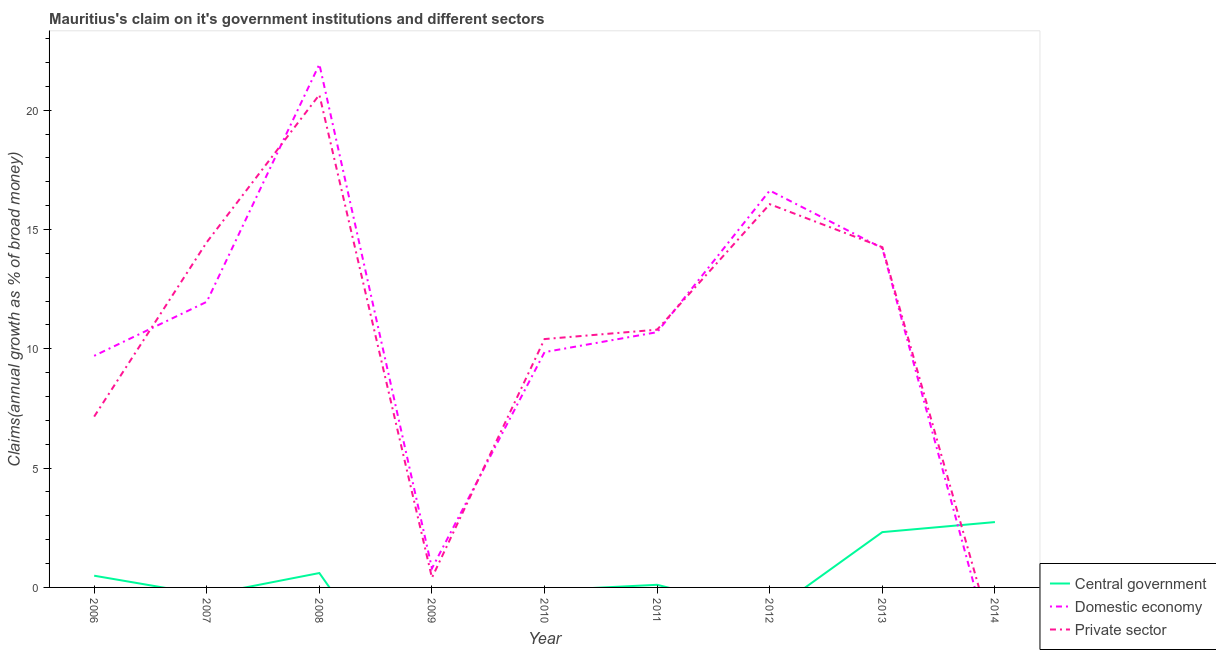How many different coloured lines are there?
Give a very brief answer. 3. Does the line corresponding to percentage of claim on the private sector intersect with the line corresponding to percentage of claim on the central government?
Provide a succinct answer. Yes. What is the percentage of claim on the private sector in 2008?
Your answer should be very brief. 20.65. Across all years, what is the maximum percentage of claim on the central government?
Provide a succinct answer. 2.74. Across all years, what is the minimum percentage of claim on the domestic economy?
Offer a very short reply. 0. In which year was the percentage of claim on the domestic economy maximum?
Provide a succinct answer. 2008. What is the total percentage of claim on the central government in the graph?
Ensure brevity in your answer.  6.26. What is the difference between the percentage of claim on the domestic economy in 2010 and that in 2013?
Your answer should be compact. -4.36. What is the difference between the percentage of claim on the private sector in 2007 and the percentage of claim on the central government in 2010?
Your answer should be very brief. 14.47. What is the average percentage of claim on the central government per year?
Provide a short and direct response. 0.7. In the year 2009, what is the difference between the percentage of claim on the domestic economy and percentage of claim on the private sector?
Give a very brief answer. 0.39. What is the ratio of the percentage of claim on the domestic economy in 2006 to that in 2007?
Your response must be concise. 0.81. Is the percentage of claim on the private sector in 2011 less than that in 2012?
Ensure brevity in your answer.  Yes. Is the difference between the percentage of claim on the private sector in 2006 and 2012 greater than the difference between the percentage of claim on the domestic economy in 2006 and 2012?
Provide a short and direct response. No. What is the difference between the highest and the second highest percentage of claim on the central government?
Provide a succinct answer. 0.42. What is the difference between the highest and the lowest percentage of claim on the domestic economy?
Your response must be concise. 21.92. In how many years, is the percentage of claim on the central government greater than the average percentage of claim on the central government taken over all years?
Offer a very short reply. 2. Is it the case that in every year, the sum of the percentage of claim on the central government and percentage of claim on the domestic economy is greater than the percentage of claim on the private sector?
Offer a terse response. No. Is the percentage of claim on the central government strictly greater than the percentage of claim on the domestic economy over the years?
Make the answer very short. No. Is the percentage of claim on the domestic economy strictly less than the percentage of claim on the private sector over the years?
Provide a short and direct response. No. Does the graph contain any zero values?
Keep it short and to the point. Yes. Does the graph contain grids?
Offer a very short reply. No. How many legend labels are there?
Your answer should be very brief. 3. What is the title of the graph?
Make the answer very short. Mauritius's claim on it's government institutions and different sectors. Does "Resident buildings and public services" appear as one of the legend labels in the graph?
Provide a succinct answer. No. What is the label or title of the Y-axis?
Provide a short and direct response. Claims(annual growth as % of broad money). What is the Claims(annual growth as % of broad money) in Central government in 2006?
Make the answer very short. 0.49. What is the Claims(annual growth as % of broad money) of Domestic economy in 2006?
Make the answer very short. 9.7. What is the Claims(annual growth as % of broad money) of Private sector in 2006?
Offer a very short reply. 7.16. What is the Claims(annual growth as % of broad money) in Central government in 2007?
Keep it short and to the point. 0. What is the Claims(annual growth as % of broad money) in Domestic economy in 2007?
Your answer should be compact. 11.97. What is the Claims(annual growth as % of broad money) in Private sector in 2007?
Your answer should be very brief. 14.47. What is the Claims(annual growth as % of broad money) in Central government in 2008?
Your answer should be very brief. 0.6. What is the Claims(annual growth as % of broad money) of Domestic economy in 2008?
Keep it short and to the point. 21.92. What is the Claims(annual growth as % of broad money) in Private sector in 2008?
Your response must be concise. 20.65. What is the Claims(annual growth as % of broad money) in Domestic economy in 2009?
Make the answer very short. 0.8. What is the Claims(annual growth as % of broad money) of Private sector in 2009?
Provide a short and direct response. 0.41. What is the Claims(annual growth as % of broad money) of Domestic economy in 2010?
Keep it short and to the point. 9.86. What is the Claims(annual growth as % of broad money) of Private sector in 2010?
Keep it short and to the point. 10.41. What is the Claims(annual growth as % of broad money) in Central government in 2011?
Offer a terse response. 0.11. What is the Claims(annual growth as % of broad money) in Domestic economy in 2011?
Keep it short and to the point. 10.7. What is the Claims(annual growth as % of broad money) of Private sector in 2011?
Your answer should be very brief. 10.8. What is the Claims(annual growth as % of broad money) of Domestic economy in 2012?
Provide a short and direct response. 16.63. What is the Claims(annual growth as % of broad money) of Private sector in 2012?
Offer a very short reply. 16.06. What is the Claims(annual growth as % of broad money) of Central government in 2013?
Your answer should be compact. 2.32. What is the Claims(annual growth as % of broad money) in Domestic economy in 2013?
Your answer should be very brief. 14.22. What is the Claims(annual growth as % of broad money) of Private sector in 2013?
Ensure brevity in your answer.  14.26. What is the Claims(annual growth as % of broad money) in Central government in 2014?
Offer a very short reply. 2.74. Across all years, what is the maximum Claims(annual growth as % of broad money) in Central government?
Offer a very short reply. 2.74. Across all years, what is the maximum Claims(annual growth as % of broad money) of Domestic economy?
Provide a short and direct response. 21.92. Across all years, what is the maximum Claims(annual growth as % of broad money) in Private sector?
Provide a succinct answer. 20.65. Across all years, what is the minimum Claims(annual growth as % of broad money) in Domestic economy?
Your answer should be compact. 0. What is the total Claims(annual growth as % of broad money) in Central government in the graph?
Your answer should be very brief. 6.26. What is the total Claims(annual growth as % of broad money) in Domestic economy in the graph?
Your answer should be compact. 95.8. What is the total Claims(annual growth as % of broad money) in Private sector in the graph?
Provide a short and direct response. 94.2. What is the difference between the Claims(annual growth as % of broad money) in Domestic economy in 2006 and that in 2007?
Provide a succinct answer. -2.27. What is the difference between the Claims(annual growth as % of broad money) in Private sector in 2006 and that in 2007?
Give a very brief answer. -7.31. What is the difference between the Claims(annual growth as % of broad money) in Central government in 2006 and that in 2008?
Ensure brevity in your answer.  -0.11. What is the difference between the Claims(annual growth as % of broad money) in Domestic economy in 2006 and that in 2008?
Make the answer very short. -12.22. What is the difference between the Claims(annual growth as % of broad money) in Private sector in 2006 and that in 2008?
Keep it short and to the point. -13.49. What is the difference between the Claims(annual growth as % of broad money) in Domestic economy in 2006 and that in 2009?
Keep it short and to the point. 8.91. What is the difference between the Claims(annual growth as % of broad money) of Private sector in 2006 and that in 2009?
Ensure brevity in your answer.  6.75. What is the difference between the Claims(annual growth as % of broad money) in Domestic economy in 2006 and that in 2010?
Keep it short and to the point. -0.16. What is the difference between the Claims(annual growth as % of broad money) of Private sector in 2006 and that in 2010?
Give a very brief answer. -3.25. What is the difference between the Claims(annual growth as % of broad money) of Central government in 2006 and that in 2011?
Your answer should be compact. 0.38. What is the difference between the Claims(annual growth as % of broad money) in Domestic economy in 2006 and that in 2011?
Offer a very short reply. -0.99. What is the difference between the Claims(annual growth as % of broad money) in Private sector in 2006 and that in 2011?
Keep it short and to the point. -3.64. What is the difference between the Claims(annual growth as % of broad money) in Domestic economy in 2006 and that in 2012?
Keep it short and to the point. -6.93. What is the difference between the Claims(annual growth as % of broad money) of Private sector in 2006 and that in 2012?
Provide a succinct answer. -8.9. What is the difference between the Claims(annual growth as % of broad money) in Central government in 2006 and that in 2013?
Your answer should be very brief. -1.83. What is the difference between the Claims(annual growth as % of broad money) of Domestic economy in 2006 and that in 2013?
Your answer should be very brief. -4.51. What is the difference between the Claims(annual growth as % of broad money) in Private sector in 2006 and that in 2013?
Your response must be concise. -7.1. What is the difference between the Claims(annual growth as % of broad money) of Central government in 2006 and that in 2014?
Offer a terse response. -2.25. What is the difference between the Claims(annual growth as % of broad money) in Domestic economy in 2007 and that in 2008?
Offer a very short reply. -9.95. What is the difference between the Claims(annual growth as % of broad money) of Private sector in 2007 and that in 2008?
Provide a succinct answer. -6.18. What is the difference between the Claims(annual growth as % of broad money) in Domestic economy in 2007 and that in 2009?
Offer a terse response. 11.17. What is the difference between the Claims(annual growth as % of broad money) of Private sector in 2007 and that in 2009?
Your answer should be compact. 14.06. What is the difference between the Claims(annual growth as % of broad money) of Domestic economy in 2007 and that in 2010?
Your answer should be very brief. 2.11. What is the difference between the Claims(annual growth as % of broad money) in Private sector in 2007 and that in 2010?
Give a very brief answer. 4.06. What is the difference between the Claims(annual growth as % of broad money) in Domestic economy in 2007 and that in 2011?
Keep it short and to the point. 1.27. What is the difference between the Claims(annual growth as % of broad money) of Private sector in 2007 and that in 2011?
Your answer should be very brief. 3.67. What is the difference between the Claims(annual growth as % of broad money) in Domestic economy in 2007 and that in 2012?
Provide a succinct answer. -4.66. What is the difference between the Claims(annual growth as % of broad money) of Private sector in 2007 and that in 2012?
Offer a terse response. -1.59. What is the difference between the Claims(annual growth as % of broad money) of Domestic economy in 2007 and that in 2013?
Offer a very short reply. -2.25. What is the difference between the Claims(annual growth as % of broad money) in Private sector in 2007 and that in 2013?
Your response must be concise. 0.21. What is the difference between the Claims(annual growth as % of broad money) in Domestic economy in 2008 and that in 2009?
Ensure brevity in your answer.  21.12. What is the difference between the Claims(annual growth as % of broad money) in Private sector in 2008 and that in 2009?
Your answer should be compact. 20.24. What is the difference between the Claims(annual growth as % of broad money) of Domestic economy in 2008 and that in 2010?
Give a very brief answer. 12.06. What is the difference between the Claims(annual growth as % of broad money) of Private sector in 2008 and that in 2010?
Your response must be concise. 10.24. What is the difference between the Claims(annual growth as % of broad money) of Central government in 2008 and that in 2011?
Your response must be concise. 0.49. What is the difference between the Claims(annual growth as % of broad money) in Domestic economy in 2008 and that in 2011?
Provide a succinct answer. 11.23. What is the difference between the Claims(annual growth as % of broad money) of Private sector in 2008 and that in 2011?
Make the answer very short. 9.84. What is the difference between the Claims(annual growth as % of broad money) of Domestic economy in 2008 and that in 2012?
Your answer should be compact. 5.29. What is the difference between the Claims(annual growth as % of broad money) of Private sector in 2008 and that in 2012?
Make the answer very short. 4.59. What is the difference between the Claims(annual growth as % of broad money) of Central government in 2008 and that in 2013?
Your answer should be compact. -1.72. What is the difference between the Claims(annual growth as % of broad money) in Domestic economy in 2008 and that in 2013?
Provide a succinct answer. 7.7. What is the difference between the Claims(annual growth as % of broad money) of Private sector in 2008 and that in 2013?
Give a very brief answer. 6.39. What is the difference between the Claims(annual growth as % of broad money) of Central government in 2008 and that in 2014?
Your response must be concise. -2.14. What is the difference between the Claims(annual growth as % of broad money) in Domestic economy in 2009 and that in 2010?
Your answer should be very brief. -9.06. What is the difference between the Claims(annual growth as % of broad money) of Private sector in 2009 and that in 2010?
Keep it short and to the point. -10. What is the difference between the Claims(annual growth as % of broad money) in Domestic economy in 2009 and that in 2011?
Your answer should be compact. -9.9. What is the difference between the Claims(annual growth as % of broad money) in Private sector in 2009 and that in 2011?
Offer a very short reply. -10.39. What is the difference between the Claims(annual growth as % of broad money) in Domestic economy in 2009 and that in 2012?
Provide a succinct answer. -15.83. What is the difference between the Claims(annual growth as % of broad money) of Private sector in 2009 and that in 2012?
Provide a succinct answer. -15.65. What is the difference between the Claims(annual growth as % of broad money) of Domestic economy in 2009 and that in 2013?
Provide a short and direct response. -13.42. What is the difference between the Claims(annual growth as % of broad money) of Private sector in 2009 and that in 2013?
Ensure brevity in your answer.  -13.85. What is the difference between the Claims(annual growth as % of broad money) of Domestic economy in 2010 and that in 2011?
Your response must be concise. -0.84. What is the difference between the Claims(annual growth as % of broad money) in Private sector in 2010 and that in 2011?
Your response must be concise. -0.39. What is the difference between the Claims(annual growth as % of broad money) in Domestic economy in 2010 and that in 2012?
Your answer should be compact. -6.77. What is the difference between the Claims(annual growth as % of broad money) in Private sector in 2010 and that in 2012?
Provide a short and direct response. -5.65. What is the difference between the Claims(annual growth as % of broad money) of Domestic economy in 2010 and that in 2013?
Ensure brevity in your answer.  -4.36. What is the difference between the Claims(annual growth as % of broad money) in Private sector in 2010 and that in 2013?
Your answer should be very brief. -3.85. What is the difference between the Claims(annual growth as % of broad money) of Domestic economy in 2011 and that in 2012?
Give a very brief answer. -5.93. What is the difference between the Claims(annual growth as % of broad money) in Private sector in 2011 and that in 2012?
Give a very brief answer. -5.26. What is the difference between the Claims(annual growth as % of broad money) of Central government in 2011 and that in 2013?
Make the answer very short. -2.21. What is the difference between the Claims(annual growth as % of broad money) of Domestic economy in 2011 and that in 2013?
Ensure brevity in your answer.  -3.52. What is the difference between the Claims(annual growth as % of broad money) in Private sector in 2011 and that in 2013?
Keep it short and to the point. -3.46. What is the difference between the Claims(annual growth as % of broad money) in Central government in 2011 and that in 2014?
Your response must be concise. -2.63. What is the difference between the Claims(annual growth as % of broad money) in Domestic economy in 2012 and that in 2013?
Your answer should be compact. 2.41. What is the difference between the Claims(annual growth as % of broad money) in Private sector in 2012 and that in 2013?
Make the answer very short. 1.8. What is the difference between the Claims(annual growth as % of broad money) in Central government in 2013 and that in 2014?
Give a very brief answer. -0.42. What is the difference between the Claims(annual growth as % of broad money) of Central government in 2006 and the Claims(annual growth as % of broad money) of Domestic economy in 2007?
Provide a succinct answer. -11.48. What is the difference between the Claims(annual growth as % of broad money) of Central government in 2006 and the Claims(annual growth as % of broad money) of Private sector in 2007?
Your answer should be very brief. -13.98. What is the difference between the Claims(annual growth as % of broad money) in Domestic economy in 2006 and the Claims(annual growth as % of broad money) in Private sector in 2007?
Your answer should be compact. -4.76. What is the difference between the Claims(annual growth as % of broad money) in Central government in 2006 and the Claims(annual growth as % of broad money) in Domestic economy in 2008?
Offer a very short reply. -21.43. What is the difference between the Claims(annual growth as % of broad money) in Central government in 2006 and the Claims(annual growth as % of broad money) in Private sector in 2008?
Offer a terse response. -20.15. What is the difference between the Claims(annual growth as % of broad money) of Domestic economy in 2006 and the Claims(annual growth as % of broad money) of Private sector in 2008?
Your answer should be very brief. -10.94. What is the difference between the Claims(annual growth as % of broad money) in Central government in 2006 and the Claims(annual growth as % of broad money) in Domestic economy in 2009?
Make the answer very short. -0.31. What is the difference between the Claims(annual growth as % of broad money) in Central government in 2006 and the Claims(annual growth as % of broad money) in Private sector in 2009?
Keep it short and to the point. 0.08. What is the difference between the Claims(annual growth as % of broad money) in Domestic economy in 2006 and the Claims(annual growth as % of broad money) in Private sector in 2009?
Provide a succinct answer. 9.3. What is the difference between the Claims(annual growth as % of broad money) in Central government in 2006 and the Claims(annual growth as % of broad money) in Domestic economy in 2010?
Ensure brevity in your answer.  -9.37. What is the difference between the Claims(annual growth as % of broad money) in Central government in 2006 and the Claims(annual growth as % of broad money) in Private sector in 2010?
Ensure brevity in your answer.  -9.92. What is the difference between the Claims(annual growth as % of broad money) in Domestic economy in 2006 and the Claims(annual growth as % of broad money) in Private sector in 2010?
Ensure brevity in your answer.  -0.7. What is the difference between the Claims(annual growth as % of broad money) in Central government in 2006 and the Claims(annual growth as % of broad money) in Domestic economy in 2011?
Make the answer very short. -10.21. What is the difference between the Claims(annual growth as % of broad money) in Central government in 2006 and the Claims(annual growth as % of broad money) in Private sector in 2011?
Your response must be concise. -10.31. What is the difference between the Claims(annual growth as % of broad money) in Domestic economy in 2006 and the Claims(annual growth as % of broad money) in Private sector in 2011?
Make the answer very short. -1.1. What is the difference between the Claims(annual growth as % of broad money) of Central government in 2006 and the Claims(annual growth as % of broad money) of Domestic economy in 2012?
Provide a succinct answer. -16.14. What is the difference between the Claims(annual growth as % of broad money) in Central government in 2006 and the Claims(annual growth as % of broad money) in Private sector in 2012?
Give a very brief answer. -15.57. What is the difference between the Claims(annual growth as % of broad money) in Domestic economy in 2006 and the Claims(annual growth as % of broad money) in Private sector in 2012?
Keep it short and to the point. -6.36. What is the difference between the Claims(annual growth as % of broad money) of Central government in 2006 and the Claims(annual growth as % of broad money) of Domestic economy in 2013?
Offer a very short reply. -13.73. What is the difference between the Claims(annual growth as % of broad money) of Central government in 2006 and the Claims(annual growth as % of broad money) of Private sector in 2013?
Make the answer very short. -13.77. What is the difference between the Claims(annual growth as % of broad money) in Domestic economy in 2006 and the Claims(annual growth as % of broad money) in Private sector in 2013?
Keep it short and to the point. -4.55. What is the difference between the Claims(annual growth as % of broad money) in Domestic economy in 2007 and the Claims(annual growth as % of broad money) in Private sector in 2008?
Provide a short and direct response. -8.68. What is the difference between the Claims(annual growth as % of broad money) in Domestic economy in 2007 and the Claims(annual growth as % of broad money) in Private sector in 2009?
Offer a terse response. 11.56. What is the difference between the Claims(annual growth as % of broad money) of Domestic economy in 2007 and the Claims(annual growth as % of broad money) of Private sector in 2010?
Your answer should be compact. 1.56. What is the difference between the Claims(annual growth as % of broad money) of Domestic economy in 2007 and the Claims(annual growth as % of broad money) of Private sector in 2011?
Your answer should be compact. 1.17. What is the difference between the Claims(annual growth as % of broad money) of Domestic economy in 2007 and the Claims(annual growth as % of broad money) of Private sector in 2012?
Give a very brief answer. -4.09. What is the difference between the Claims(annual growth as % of broad money) of Domestic economy in 2007 and the Claims(annual growth as % of broad money) of Private sector in 2013?
Provide a succinct answer. -2.29. What is the difference between the Claims(annual growth as % of broad money) of Central government in 2008 and the Claims(annual growth as % of broad money) of Domestic economy in 2009?
Ensure brevity in your answer.  -0.2. What is the difference between the Claims(annual growth as % of broad money) in Central government in 2008 and the Claims(annual growth as % of broad money) in Private sector in 2009?
Your response must be concise. 0.2. What is the difference between the Claims(annual growth as % of broad money) in Domestic economy in 2008 and the Claims(annual growth as % of broad money) in Private sector in 2009?
Give a very brief answer. 21.52. What is the difference between the Claims(annual growth as % of broad money) in Central government in 2008 and the Claims(annual growth as % of broad money) in Domestic economy in 2010?
Give a very brief answer. -9.26. What is the difference between the Claims(annual growth as % of broad money) of Central government in 2008 and the Claims(annual growth as % of broad money) of Private sector in 2010?
Your answer should be compact. -9.8. What is the difference between the Claims(annual growth as % of broad money) in Domestic economy in 2008 and the Claims(annual growth as % of broad money) in Private sector in 2010?
Provide a succinct answer. 11.52. What is the difference between the Claims(annual growth as % of broad money) of Central government in 2008 and the Claims(annual growth as % of broad money) of Domestic economy in 2011?
Make the answer very short. -10.09. What is the difference between the Claims(annual growth as % of broad money) in Central government in 2008 and the Claims(annual growth as % of broad money) in Private sector in 2011?
Ensure brevity in your answer.  -10.2. What is the difference between the Claims(annual growth as % of broad money) in Domestic economy in 2008 and the Claims(annual growth as % of broad money) in Private sector in 2011?
Your response must be concise. 11.12. What is the difference between the Claims(annual growth as % of broad money) of Central government in 2008 and the Claims(annual growth as % of broad money) of Domestic economy in 2012?
Your response must be concise. -16.03. What is the difference between the Claims(annual growth as % of broad money) of Central government in 2008 and the Claims(annual growth as % of broad money) of Private sector in 2012?
Keep it short and to the point. -15.46. What is the difference between the Claims(annual growth as % of broad money) in Domestic economy in 2008 and the Claims(annual growth as % of broad money) in Private sector in 2012?
Your response must be concise. 5.86. What is the difference between the Claims(annual growth as % of broad money) in Central government in 2008 and the Claims(annual growth as % of broad money) in Domestic economy in 2013?
Keep it short and to the point. -13.62. What is the difference between the Claims(annual growth as % of broad money) of Central government in 2008 and the Claims(annual growth as % of broad money) of Private sector in 2013?
Ensure brevity in your answer.  -13.66. What is the difference between the Claims(annual growth as % of broad money) of Domestic economy in 2008 and the Claims(annual growth as % of broad money) of Private sector in 2013?
Give a very brief answer. 7.66. What is the difference between the Claims(annual growth as % of broad money) in Domestic economy in 2009 and the Claims(annual growth as % of broad money) in Private sector in 2010?
Make the answer very short. -9.61. What is the difference between the Claims(annual growth as % of broad money) in Domestic economy in 2009 and the Claims(annual growth as % of broad money) in Private sector in 2011?
Offer a terse response. -10. What is the difference between the Claims(annual growth as % of broad money) in Domestic economy in 2009 and the Claims(annual growth as % of broad money) in Private sector in 2012?
Offer a very short reply. -15.26. What is the difference between the Claims(annual growth as % of broad money) of Domestic economy in 2009 and the Claims(annual growth as % of broad money) of Private sector in 2013?
Your answer should be compact. -13.46. What is the difference between the Claims(annual growth as % of broad money) of Domestic economy in 2010 and the Claims(annual growth as % of broad money) of Private sector in 2011?
Offer a terse response. -0.94. What is the difference between the Claims(annual growth as % of broad money) in Domestic economy in 2010 and the Claims(annual growth as % of broad money) in Private sector in 2012?
Keep it short and to the point. -6.2. What is the difference between the Claims(annual growth as % of broad money) of Domestic economy in 2010 and the Claims(annual growth as % of broad money) of Private sector in 2013?
Your response must be concise. -4.4. What is the difference between the Claims(annual growth as % of broad money) of Central government in 2011 and the Claims(annual growth as % of broad money) of Domestic economy in 2012?
Your answer should be compact. -16.52. What is the difference between the Claims(annual growth as % of broad money) of Central government in 2011 and the Claims(annual growth as % of broad money) of Private sector in 2012?
Provide a succinct answer. -15.95. What is the difference between the Claims(annual growth as % of broad money) of Domestic economy in 2011 and the Claims(annual growth as % of broad money) of Private sector in 2012?
Give a very brief answer. -5.36. What is the difference between the Claims(annual growth as % of broad money) in Central government in 2011 and the Claims(annual growth as % of broad money) in Domestic economy in 2013?
Give a very brief answer. -14.11. What is the difference between the Claims(annual growth as % of broad money) of Central government in 2011 and the Claims(annual growth as % of broad money) of Private sector in 2013?
Provide a short and direct response. -14.15. What is the difference between the Claims(annual growth as % of broad money) in Domestic economy in 2011 and the Claims(annual growth as % of broad money) in Private sector in 2013?
Your response must be concise. -3.56. What is the difference between the Claims(annual growth as % of broad money) of Domestic economy in 2012 and the Claims(annual growth as % of broad money) of Private sector in 2013?
Make the answer very short. 2.37. What is the average Claims(annual growth as % of broad money) in Central government per year?
Your response must be concise. 0.7. What is the average Claims(annual growth as % of broad money) in Domestic economy per year?
Your answer should be compact. 10.64. What is the average Claims(annual growth as % of broad money) of Private sector per year?
Ensure brevity in your answer.  10.47. In the year 2006, what is the difference between the Claims(annual growth as % of broad money) of Central government and Claims(annual growth as % of broad money) of Domestic economy?
Your response must be concise. -9.21. In the year 2006, what is the difference between the Claims(annual growth as % of broad money) of Central government and Claims(annual growth as % of broad money) of Private sector?
Provide a succinct answer. -6.67. In the year 2006, what is the difference between the Claims(annual growth as % of broad money) of Domestic economy and Claims(annual growth as % of broad money) of Private sector?
Make the answer very short. 2.55. In the year 2007, what is the difference between the Claims(annual growth as % of broad money) of Domestic economy and Claims(annual growth as % of broad money) of Private sector?
Offer a very short reply. -2.5. In the year 2008, what is the difference between the Claims(annual growth as % of broad money) of Central government and Claims(annual growth as % of broad money) of Domestic economy?
Your answer should be very brief. -21.32. In the year 2008, what is the difference between the Claims(annual growth as % of broad money) of Central government and Claims(annual growth as % of broad money) of Private sector?
Offer a terse response. -20.04. In the year 2008, what is the difference between the Claims(annual growth as % of broad money) of Domestic economy and Claims(annual growth as % of broad money) of Private sector?
Keep it short and to the point. 1.28. In the year 2009, what is the difference between the Claims(annual growth as % of broad money) of Domestic economy and Claims(annual growth as % of broad money) of Private sector?
Your answer should be very brief. 0.39. In the year 2010, what is the difference between the Claims(annual growth as % of broad money) of Domestic economy and Claims(annual growth as % of broad money) of Private sector?
Provide a succinct answer. -0.55. In the year 2011, what is the difference between the Claims(annual growth as % of broad money) of Central government and Claims(annual growth as % of broad money) of Domestic economy?
Ensure brevity in your answer.  -10.59. In the year 2011, what is the difference between the Claims(annual growth as % of broad money) of Central government and Claims(annual growth as % of broad money) of Private sector?
Provide a succinct answer. -10.69. In the year 2011, what is the difference between the Claims(annual growth as % of broad money) of Domestic economy and Claims(annual growth as % of broad money) of Private sector?
Ensure brevity in your answer.  -0.1. In the year 2012, what is the difference between the Claims(annual growth as % of broad money) in Domestic economy and Claims(annual growth as % of broad money) in Private sector?
Provide a short and direct response. 0.57. In the year 2013, what is the difference between the Claims(annual growth as % of broad money) of Central government and Claims(annual growth as % of broad money) of Domestic economy?
Provide a short and direct response. -11.9. In the year 2013, what is the difference between the Claims(annual growth as % of broad money) of Central government and Claims(annual growth as % of broad money) of Private sector?
Your answer should be very brief. -11.94. In the year 2013, what is the difference between the Claims(annual growth as % of broad money) of Domestic economy and Claims(annual growth as % of broad money) of Private sector?
Keep it short and to the point. -0.04. What is the ratio of the Claims(annual growth as % of broad money) in Domestic economy in 2006 to that in 2007?
Provide a succinct answer. 0.81. What is the ratio of the Claims(annual growth as % of broad money) of Private sector in 2006 to that in 2007?
Provide a short and direct response. 0.49. What is the ratio of the Claims(annual growth as % of broad money) in Central government in 2006 to that in 2008?
Provide a short and direct response. 0.81. What is the ratio of the Claims(annual growth as % of broad money) in Domestic economy in 2006 to that in 2008?
Keep it short and to the point. 0.44. What is the ratio of the Claims(annual growth as % of broad money) of Private sector in 2006 to that in 2008?
Keep it short and to the point. 0.35. What is the ratio of the Claims(annual growth as % of broad money) in Domestic economy in 2006 to that in 2009?
Your response must be concise. 12.15. What is the ratio of the Claims(annual growth as % of broad money) of Private sector in 2006 to that in 2009?
Offer a terse response. 17.61. What is the ratio of the Claims(annual growth as % of broad money) of Domestic economy in 2006 to that in 2010?
Your answer should be very brief. 0.98. What is the ratio of the Claims(annual growth as % of broad money) of Private sector in 2006 to that in 2010?
Your response must be concise. 0.69. What is the ratio of the Claims(annual growth as % of broad money) of Central government in 2006 to that in 2011?
Offer a terse response. 4.46. What is the ratio of the Claims(annual growth as % of broad money) of Domestic economy in 2006 to that in 2011?
Your response must be concise. 0.91. What is the ratio of the Claims(annual growth as % of broad money) in Private sector in 2006 to that in 2011?
Ensure brevity in your answer.  0.66. What is the ratio of the Claims(annual growth as % of broad money) in Domestic economy in 2006 to that in 2012?
Give a very brief answer. 0.58. What is the ratio of the Claims(annual growth as % of broad money) in Private sector in 2006 to that in 2012?
Make the answer very short. 0.45. What is the ratio of the Claims(annual growth as % of broad money) in Central government in 2006 to that in 2013?
Give a very brief answer. 0.21. What is the ratio of the Claims(annual growth as % of broad money) in Domestic economy in 2006 to that in 2013?
Your answer should be very brief. 0.68. What is the ratio of the Claims(annual growth as % of broad money) of Private sector in 2006 to that in 2013?
Give a very brief answer. 0.5. What is the ratio of the Claims(annual growth as % of broad money) of Central government in 2006 to that in 2014?
Make the answer very short. 0.18. What is the ratio of the Claims(annual growth as % of broad money) in Domestic economy in 2007 to that in 2008?
Your answer should be compact. 0.55. What is the ratio of the Claims(annual growth as % of broad money) in Private sector in 2007 to that in 2008?
Offer a very short reply. 0.7. What is the ratio of the Claims(annual growth as % of broad money) of Domestic economy in 2007 to that in 2009?
Your response must be concise. 14.99. What is the ratio of the Claims(annual growth as % of broad money) in Private sector in 2007 to that in 2009?
Your response must be concise. 35.58. What is the ratio of the Claims(annual growth as % of broad money) in Domestic economy in 2007 to that in 2010?
Provide a succinct answer. 1.21. What is the ratio of the Claims(annual growth as % of broad money) in Private sector in 2007 to that in 2010?
Keep it short and to the point. 1.39. What is the ratio of the Claims(annual growth as % of broad money) in Domestic economy in 2007 to that in 2011?
Provide a short and direct response. 1.12. What is the ratio of the Claims(annual growth as % of broad money) in Private sector in 2007 to that in 2011?
Your answer should be compact. 1.34. What is the ratio of the Claims(annual growth as % of broad money) of Domestic economy in 2007 to that in 2012?
Ensure brevity in your answer.  0.72. What is the ratio of the Claims(annual growth as % of broad money) of Private sector in 2007 to that in 2012?
Provide a succinct answer. 0.9. What is the ratio of the Claims(annual growth as % of broad money) of Domestic economy in 2007 to that in 2013?
Provide a short and direct response. 0.84. What is the ratio of the Claims(annual growth as % of broad money) of Private sector in 2007 to that in 2013?
Your answer should be compact. 1.01. What is the ratio of the Claims(annual growth as % of broad money) in Domestic economy in 2008 to that in 2009?
Your answer should be very brief. 27.45. What is the ratio of the Claims(annual growth as % of broad money) in Private sector in 2008 to that in 2009?
Your answer should be compact. 50.78. What is the ratio of the Claims(annual growth as % of broad money) in Domestic economy in 2008 to that in 2010?
Give a very brief answer. 2.22. What is the ratio of the Claims(annual growth as % of broad money) in Private sector in 2008 to that in 2010?
Offer a terse response. 1.98. What is the ratio of the Claims(annual growth as % of broad money) in Central government in 2008 to that in 2011?
Your answer should be compact. 5.48. What is the ratio of the Claims(annual growth as % of broad money) of Domestic economy in 2008 to that in 2011?
Your response must be concise. 2.05. What is the ratio of the Claims(annual growth as % of broad money) in Private sector in 2008 to that in 2011?
Your response must be concise. 1.91. What is the ratio of the Claims(annual growth as % of broad money) in Domestic economy in 2008 to that in 2012?
Provide a short and direct response. 1.32. What is the ratio of the Claims(annual growth as % of broad money) of Private sector in 2008 to that in 2012?
Ensure brevity in your answer.  1.29. What is the ratio of the Claims(annual growth as % of broad money) in Central government in 2008 to that in 2013?
Ensure brevity in your answer.  0.26. What is the ratio of the Claims(annual growth as % of broad money) of Domestic economy in 2008 to that in 2013?
Give a very brief answer. 1.54. What is the ratio of the Claims(annual growth as % of broad money) of Private sector in 2008 to that in 2013?
Your response must be concise. 1.45. What is the ratio of the Claims(annual growth as % of broad money) of Central government in 2008 to that in 2014?
Ensure brevity in your answer.  0.22. What is the ratio of the Claims(annual growth as % of broad money) in Domestic economy in 2009 to that in 2010?
Your response must be concise. 0.08. What is the ratio of the Claims(annual growth as % of broad money) in Private sector in 2009 to that in 2010?
Ensure brevity in your answer.  0.04. What is the ratio of the Claims(annual growth as % of broad money) of Domestic economy in 2009 to that in 2011?
Your response must be concise. 0.07. What is the ratio of the Claims(annual growth as % of broad money) in Private sector in 2009 to that in 2011?
Offer a terse response. 0.04. What is the ratio of the Claims(annual growth as % of broad money) in Domestic economy in 2009 to that in 2012?
Ensure brevity in your answer.  0.05. What is the ratio of the Claims(annual growth as % of broad money) in Private sector in 2009 to that in 2012?
Keep it short and to the point. 0.03. What is the ratio of the Claims(annual growth as % of broad money) of Domestic economy in 2009 to that in 2013?
Give a very brief answer. 0.06. What is the ratio of the Claims(annual growth as % of broad money) of Private sector in 2009 to that in 2013?
Provide a succinct answer. 0.03. What is the ratio of the Claims(annual growth as % of broad money) of Domestic economy in 2010 to that in 2011?
Ensure brevity in your answer.  0.92. What is the ratio of the Claims(annual growth as % of broad money) of Private sector in 2010 to that in 2011?
Your answer should be compact. 0.96. What is the ratio of the Claims(annual growth as % of broad money) in Domestic economy in 2010 to that in 2012?
Ensure brevity in your answer.  0.59. What is the ratio of the Claims(annual growth as % of broad money) of Private sector in 2010 to that in 2012?
Provide a short and direct response. 0.65. What is the ratio of the Claims(annual growth as % of broad money) of Domestic economy in 2010 to that in 2013?
Your answer should be compact. 0.69. What is the ratio of the Claims(annual growth as % of broad money) of Private sector in 2010 to that in 2013?
Give a very brief answer. 0.73. What is the ratio of the Claims(annual growth as % of broad money) in Domestic economy in 2011 to that in 2012?
Your response must be concise. 0.64. What is the ratio of the Claims(annual growth as % of broad money) in Private sector in 2011 to that in 2012?
Make the answer very short. 0.67. What is the ratio of the Claims(annual growth as % of broad money) of Central government in 2011 to that in 2013?
Your answer should be compact. 0.05. What is the ratio of the Claims(annual growth as % of broad money) in Domestic economy in 2011 to that in 2013?
Make the answer very short. 0.75. What is the ratio of the Claims(annual growth as % of broad money) of Private sector in 2011 to that in 2013?
Make the answer very short. 0.76. What is the ratio of the Claims(annual growth as % of broad money) of Central government in 2011 to that in 2014?
Make the answer very short. 0.04. What is the ratio of the Claims(annual growth as % of broad money) of Domestic economy in 2012 to that in 2013?
Offer a terse response. 1.17. What is the ratio of the Claims(annual growth as % of broad money) of Private sector in 2012 to that in 2013?
Give a very brief answer. 1.13. What is the ratio of the Claims(annual growth as % of broad money) in Central government in 2013 to that in 2014?
Give a very brief answer. 0.85. What is the difference between the highest and the second highest Claims(annual growth as % of broad money) in Central government?
Give a very brief answer. 0.42. What is the difference between the highest and the second highest Claims(annual growth as % of broad money) in Domestic economy?
Your response must be concise. 5.29. What is the difference between the highest and the second highest Claims(annual growth as % of broad money) in Private sector?
Give a very brief answer. 4.59. What is the difference between the highest and the lowest Claims(annual growth as % of broad money) of Central government?
Give a very brief answer. 2.74. What is the difference between the highest and the lowest Claims(annual growth as % of broad money) in Domestic economy?
Ensure brevity in your answer.  21.92. What is the difference between the highest and the lowest Claims(annual growth as % of broad money) of Private sector?
Offer a very short reply. 20.65. 